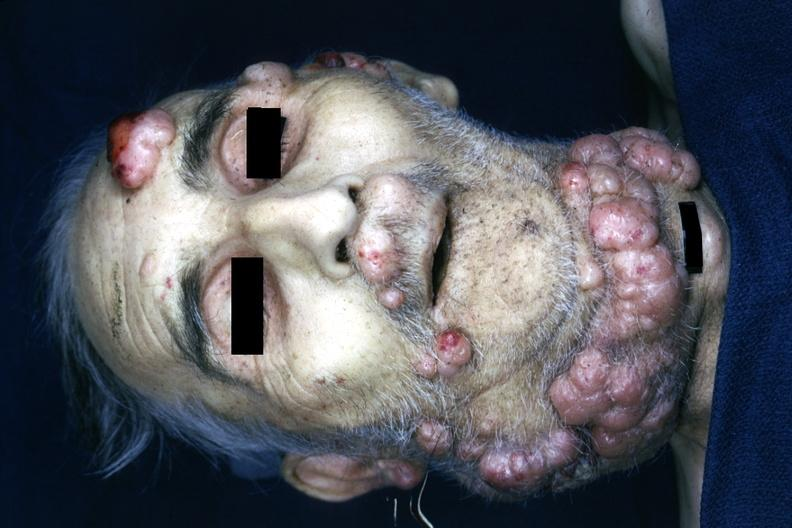what recklinghausens disease is present?
Answer the question using a single word or phrase. Von 